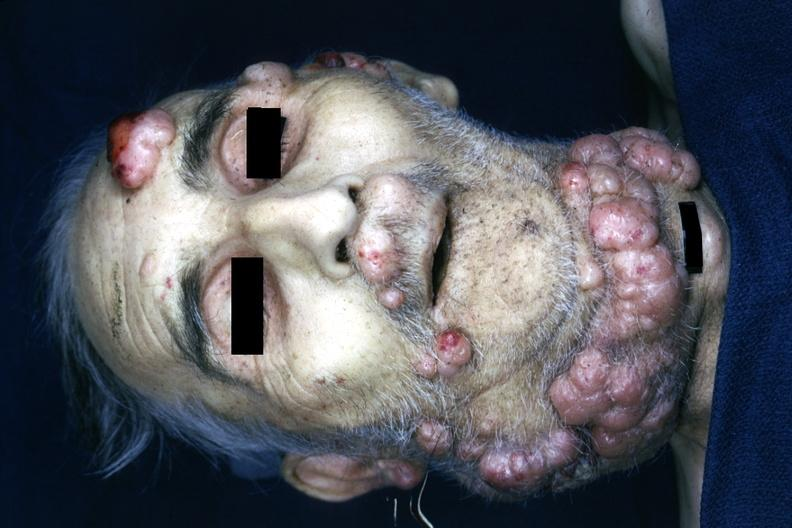what recklinghausens disease is present?
Answer the question using a single word or phrase. Von 